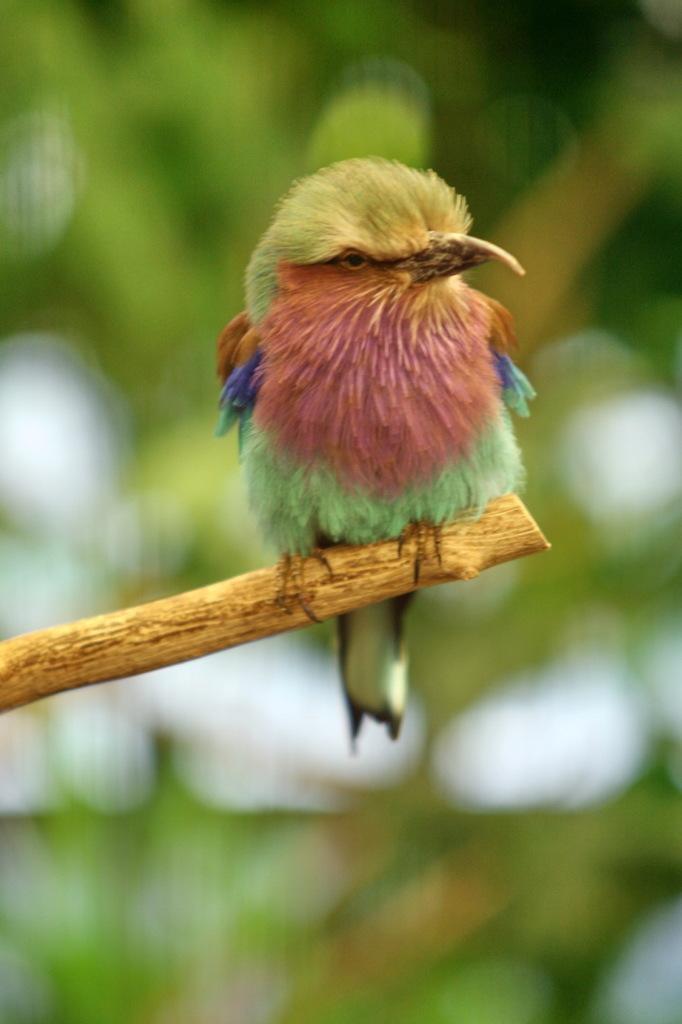Could you give a brief overview of what you see in this image? In the center of the image we can see a bird on the branch. 